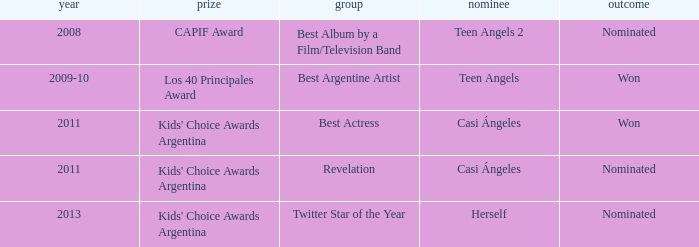Would you be able to parse every entry in this table? {'header': ['year', 'prize', 'group', 'nominee', 'outcome'], 'rows': [['2008', 'CAPIF Award', 'Best Album by a Film/Television Band', 'Teen Angels 2', 'Nominated'], ['2009-10', 'Los 40 Principales Award', 'Best Argentine Artist', 'Teen Angels', 'Won'], ['2011', "Kids' Choice Awards Argentina", 'Best Actress', 'Casi Ángeles', 'Won'], ['2011', "Kids' Choice Awards Argentina", 'Revelation', 'Casi Ángeles', 'Nominated'], ['2013', "Kids' Choice Awards Argentina", 'Twitter Star of the Year', 'Herself', 'Nominated']]} Name the performance nominated for a Capif Award. Teen Angels 2. 